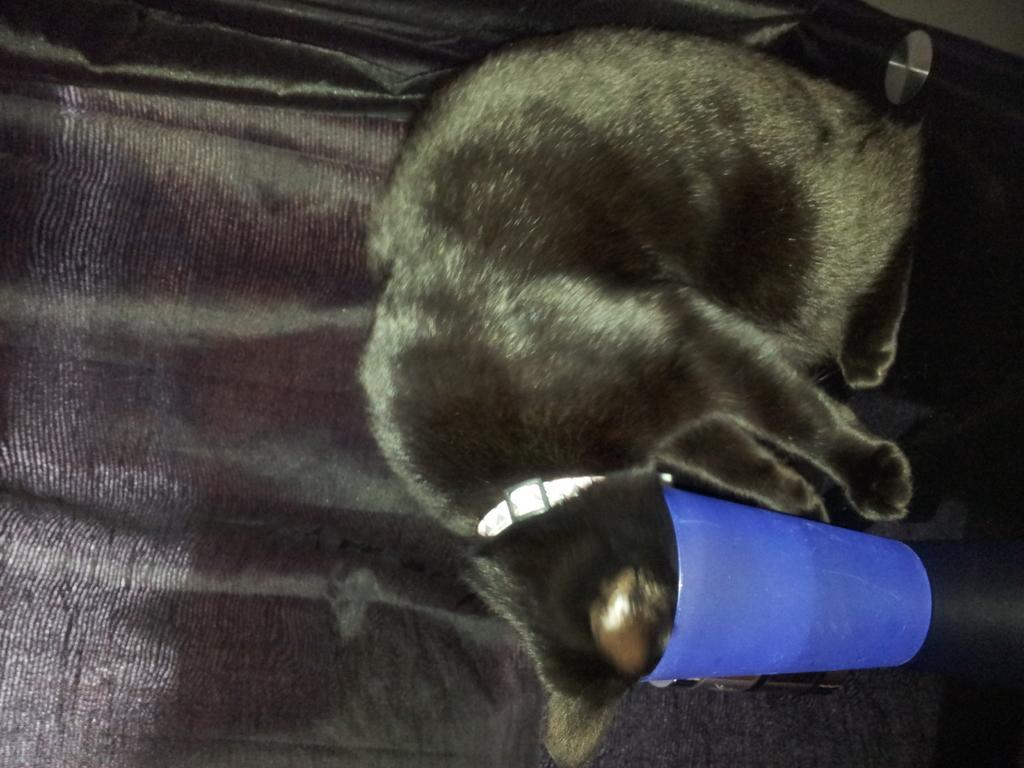How would you summarize this image in a sentence or two? In this image we can see an animal, glass and an object. The background of the image is black. 